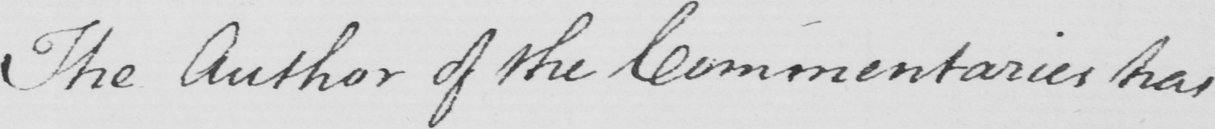Can you tell me what this handwritten text says? The Author of the Commentaries has 